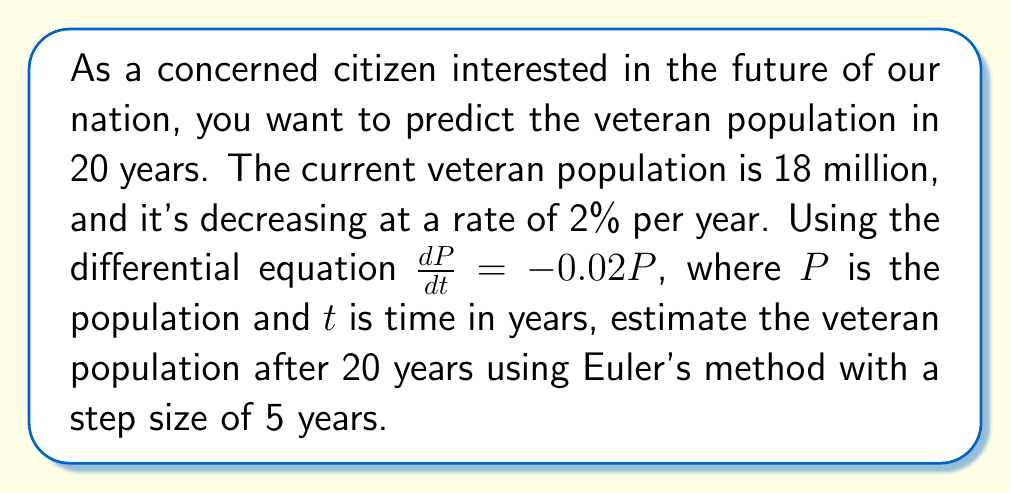Can you answer this question? To solve this problem using Euler's method, we'll follow these steps:

1) The differential equation is $\frac{dP}{dt} = -0.02P$

2) Initial conditions: $P_0 = 18$ million, $t_0 = 0$

3) We need to find $P$ at $t = 20$ years

4) Step size $h = 5$ years

5) Euler's method formula: $P_{n+1} = P_n + h \cdot f(t_n, P_n)$
   Where $f(t, P) = -0.02P$

6) We'll need to iterate 4 times (20 years / 5-year steps = 4 iterations)

Iteration 1 ($t = 5$):
$P_1 = P_0 + h \cdot f(t_0, P_0) = 18 + 5 \cdot (-0.02 \cdot 18) = 16.2$ million

Iteration 2 ($t = 10$):
$P_2 = P_1 + h \cdot f(t_1, P_1) = 16.2 + 5 \cdot (-0.02 \cdot 16.2) = 14.58$ million

Iteration 3 ($t = 15$):
$P_3 = P_2 + h \cdot f(t_2, P_2) = 14.58 + 5 \cdot (-0.02 \cdot 14.58) = 13.122$ million

Iteration 4 ($t = 20$):
$P_4 = P_3 + h \cdot f(t_3, P_3) = 13.122 + 5 \cdot (-0.02 \cdot 13.122) = 11.8098$ million

Therefore, the estimated veteran population after 20 years is approximately 11.81 million.
Answer: 11.81 million veterans 